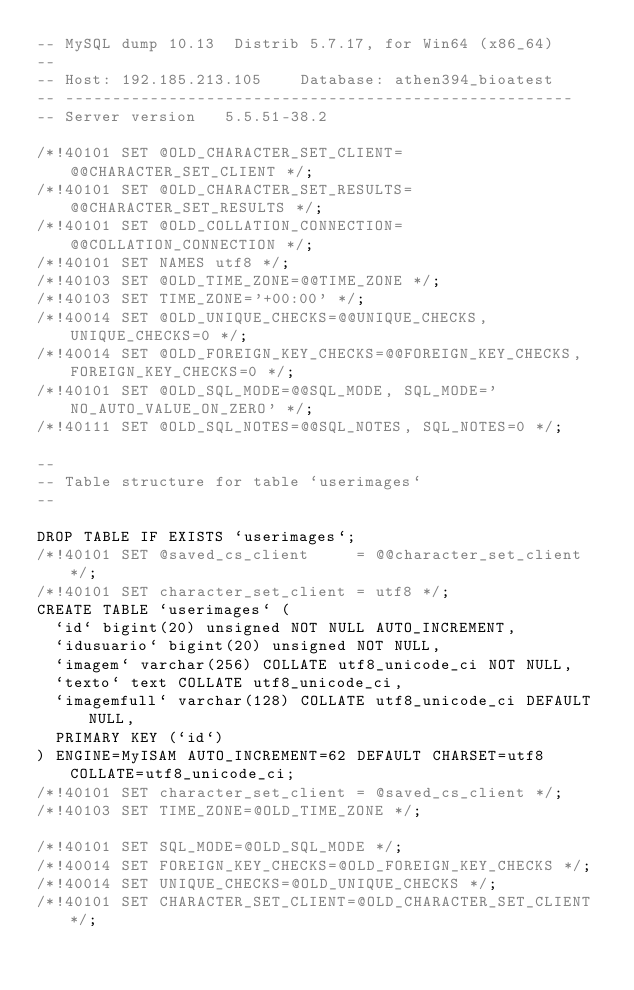Convert code to text. <code><loc_0><loc_0><loc_500><loc_500><_SQL_>-- MySQL dump 10.13  Distrib 5.7.17, for Win64 (x86_64)
--
-- Host: 192.185.213.105    Database: athen394_bioatest
-- ------------------------------------------------------
-- Server version	5.5.51-38.2

/*!40101 SET @OLD_CHARACTER_SET_CLIENT=@@CHARACTER_SET_CLIENT */;
/*!40101 SET @OLD_CHARACTER_SET_RESULTS=@@CHARACTER_SET_RESULTS */;
/*!40101 SET @OLD_COLLATION_CONNECTION=@@COLLATION_CONNECTION */;
/*!40101 SET NAMES utf8 */;
/*!40103 SET @OLD_TIME_ZONE=@@TIME_ZONE */;
/*!40103 SET TIME_ZONE='+00:00' */;
/*!40014 SET @OLD_UNIQUE_CHECKS=@@UNIQUE_CHECKS, UNIQUE_CHECKS=0 */;
/*!40014 SET @OLD_FOREIGN_KEY_CHECKS=@@FOREIGN_KEY_CHECKS, FOREIGN_KEY_CHECKS=0 */;
/*!40101 SET @OLD_SQL_MODE=@@SQL_MODE, SQL_MODE='NO_AUTO_VALUE_ON_ZERO' */;
/*!40111 SET @OLD_SQL_NOTES=@@SQL_NOTES, SQL_NOTES=0 */;

--
-- Table structure for table `userimages`
--

DROP TABLE IF EXISTS `userimages`;
/*!40101 SET @saved_cs_client     = @@character_set_client */;
/*!40101 SET character_set_client = utf8 */;
CREATE TABLE `userimages` (
  `id` bigint(20) unsigned NOT NULL AUTO_INCREMENT,
  `idusuario` bigint(20) unsigned NOT NULL,
  `imagem` varchar(256) COLLATE utf8_unicode_ci NOT NULL,
  `texto` text COLLATE utf8_unicode_ci,
  `imagemfull` varchar(128) COLLATE utf8_unicode_ci DEFAULT NULL,
  PRIMARY KEY (`id`)
) ENGINE=MyISAM AUTO_INCREMENT=62 DEFAULT CHARSET=utf8 COLLATE=utf8_unicode_ci;
/*!40101 SET character_set_client = @saved_cs_client */;
/*!40103 SET TIME_ZONE=@OLD_TIME_ZONE */;

/*!40101 SET SQL_MODE=@OLD_SQL_MODE */;
/*!40014 SET FOREIGN_KEY_CHECKS=@OLD_FOREIGN_KEY_CHECKS */;
/*!40014 SET UNIQUE_CHECKS=@OLD_UNIQUE_CHECKS */;
/*!40101 SET CHARACTER_SET_CLIENT=@OLD_CHARACTER_SET_CLIENT */;</code> 